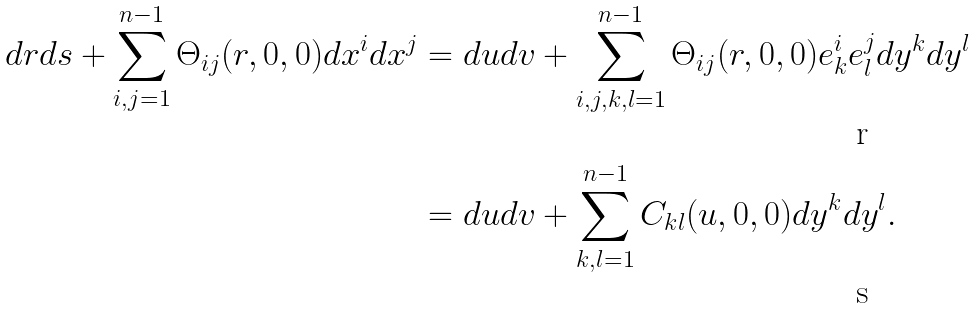Convert formula to latex. <formula><loc_0><loc_0><loc_500><loc_500>d r d s + \sum _ { i , j = 1 } ^ { n - 1 } \Theta _ { i j } ( r , 0 , 0 ) d x ^ { i } d x ^ { j } & = d u d v + \sum _ { i , j , k , l = 1 } ^ { n - 1 } \Theta _ { i j } ( r , 0 , 0 ) e ^ { i } _ { k } e ^ { j } _ { l } d y ^ { k } d y ^ { l } \\ & = d u d v + \sum _ { k , l = 1 } ^ { n - 1 } C _ { k l } ( u , 0 , 0 ) d y ^ { k } d y ^ { l } .</formula> 